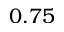Convert formula to latex. <formula><loc_0><loc_0><loc_500><loc_500>0 . 7 5</formula> 